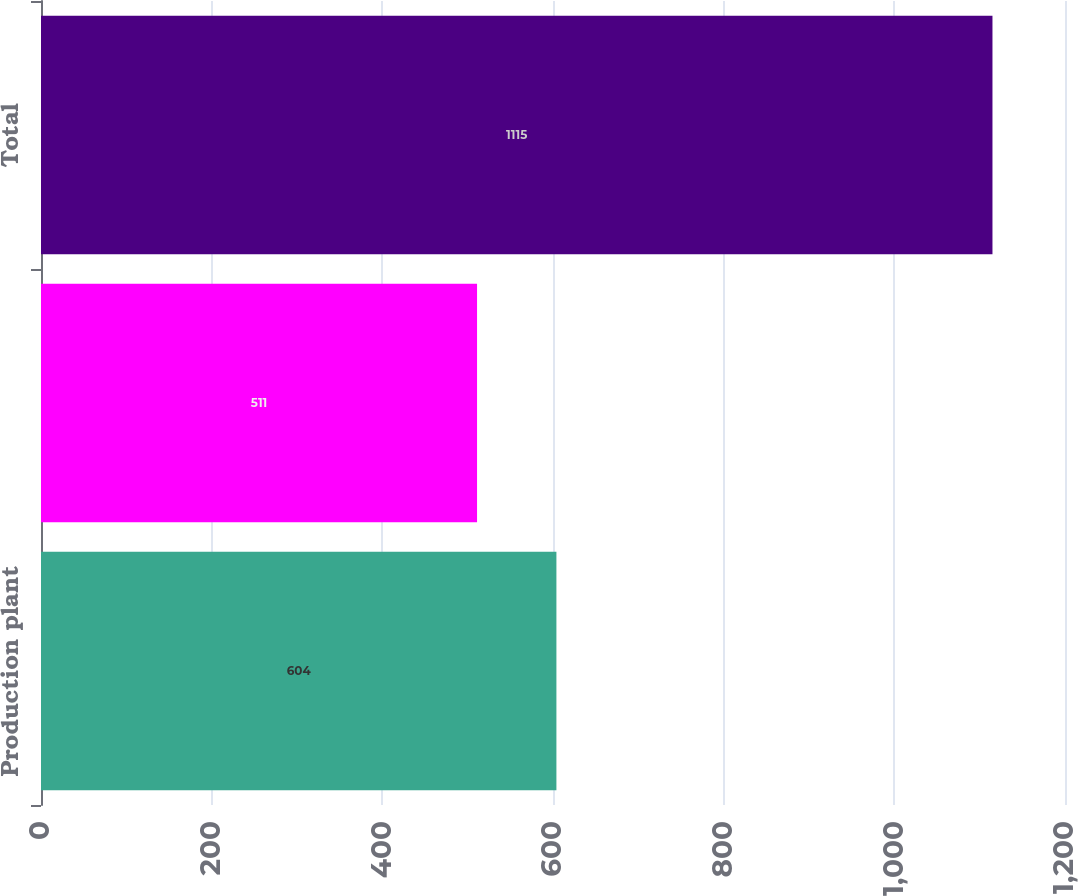Convert chart to OTSL. <chart><loc_0><loc_0><loc_500><loc_500><bar_chart><fcel>Production plant<fcel>Nuclearfuel<fcel>Total<nl><fcel>604<fcel>511<fcel>1115<nl></chart> 